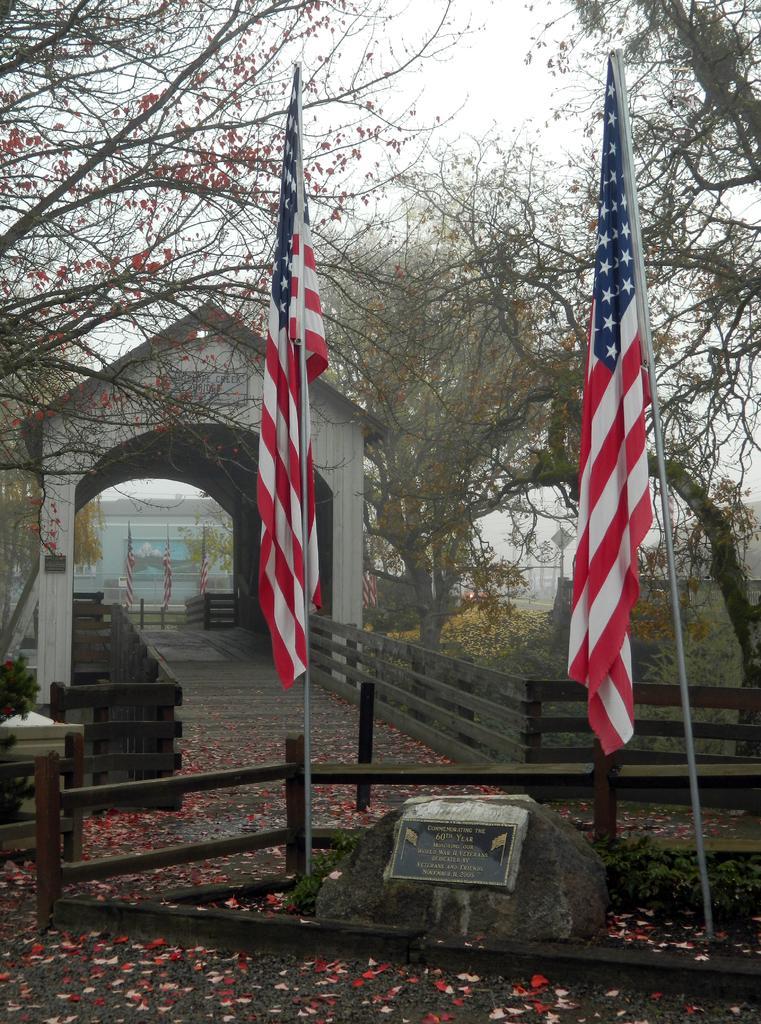Could you give a brief overview of what you see in this image? Here we can see two flags,two poles on the ground. We can see fence,bridge,name board on a stone,petals on the ground and bridge. In the background there are buildings,poles,flags,trees and sky. 